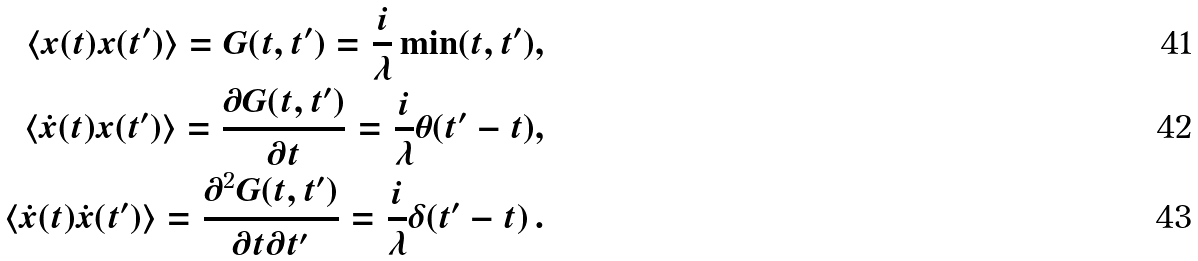<formula> <loc_0><loc_0><loc_500><loc_500>\langle x ( t ) x ( t ^ { \prime } ) \rangle = G ( t , t ^ { \prime } ) = \frac { i } { \lambda } \min ( t , t ^ { \prime } ) , \\ \langle \dot { x } ( t ) x ( t ^ { \prime } ) \rangle = \frac { \partial G ( t , t ^ { \prime } ) } { \partial t } = \frac { i } { \lambda } \theta ( t ^ { \prime } - t ) , \\ \langle \dot { x } ( t ) \dot { x } ( t ^ { \prime } ) \rangle = \frac { \partial ^ { 2 } G ( t , t ^ { \prime } ) } { \partial t \partial t ^ { \prime } } = \frac { i } { \lambda } \delta ( t ^ { \prime } - t ) \, .</formula> 